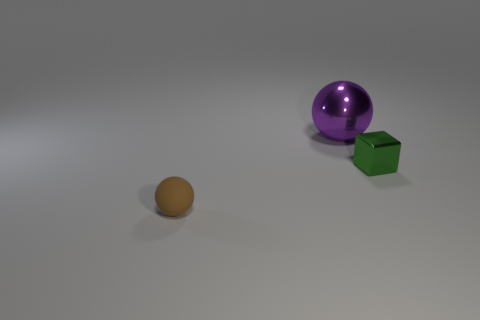What is the material of the tiny cube?
Provide a succinct answer. Metal. Do the metal thing that is behind the small metal cube and the small block have the same color?
Offer a terse response. No. Is there anything else that has the same shape as the large metallic thing?
Make the answer very short. Yes. What color is the other big thing that is the same shape as the matte object?
Make the answer very short. Purple. What is the thing that is right of the large purple metallic thing made of?
Offer a very short reply. Metal. The cube is what color?
Your answer should be very brief. Green. Is the size of the cube in front of the purple metallic ball the same as the brown sphere?
Your answer should be very brief. Yes. There is a tiny thing that is in front of the tiny thing that is right of the ball that is on the left side of the big metallic ball; what is it made of?
Make the answer very short. Rubber. There is a thing that is in front of the green metal cube; does it have the same color as the small thing that is behind the brown thing?
Ensure brevity in your answer.  No. There is a sphere that is in front of the object right of the purple metal ball; what is its material?
Keep it short and to the point. Rubber. 